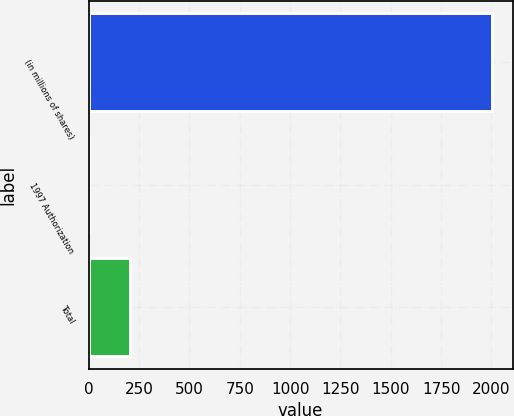<chart> <loc_0><loc_0><loc_500><loc_500><bar_chart><fcel>(in millions of shares)<fcel>1997 Authorization<fcel>Total<nl><fcel>2005<fcel>3.1<fcel>203.29<nl></chart> 